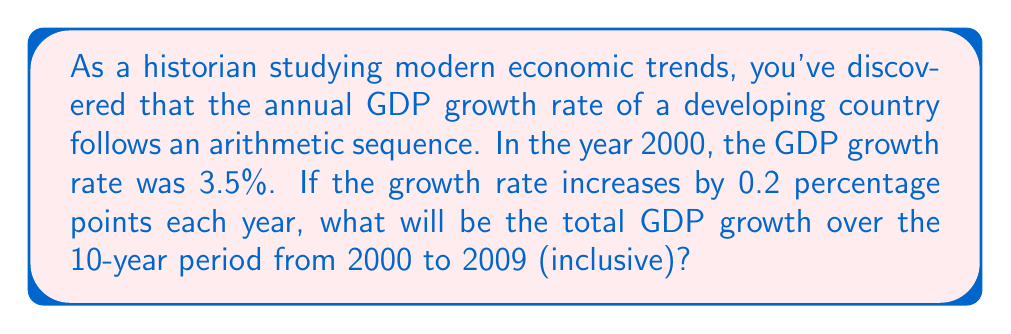Give your solution to this math problem. To solve this problem, we need to use the formula for the sum of an arithmetic sequence:

$$ S_n = \frac{n}{2}(a_1 + a_n) $$

Where:
$S_n$ is the sum of the sequence
$n$ is the number of terms
$a_1$ is the first term
$a_n$ is the last term

1. First, let's identify the components of our sequence:
   $a_1 = 3.5\%$ (first term, year 2000)
   $d = 0.2\%$ (common difference)
   $n = 10$ (number of years, 2000 to 2009 inclusive)

2. Calculate the last term ($a_n$):
   $a_n = a_1 + (n-1)d$
   $a_{10} = 3.5\% + (10-1)(0.2\%) = 3.5\% + 1.8\% = 5.3\%$

3. Now we can apply the sum formula:
   $$ S_{10} = \frac{10}{2}(3.5\% + 5.3\%) = 5(8.8\%) = 44\% $$

This 44% represents the sum of the annual growth rates over the 10-year period. However, to calculate the total GDP growth, we need to compound these growth rates.

4. The formula for compound growth is:
   $$ \text{Total Growth} = \prod_{i=1}^{10} (1 + r_i) - 1 $$
   Where $r_i$ is the growth rate for each year.

5. Calculating this:
   $(1.035)(1.037)(1.039)(1.041)(1.043)(1.045)(1.047)(1.049)(1.051)(1.053) - 1$
   $= 1.4859 - 1 = 0.4859$

6. Convert to percentage:
   $0.4859 \times 100\% = 48.59\%$
Answer: The total GDP growth over the 10-year period from 2000 to 2009 is approximately 48.59%. 